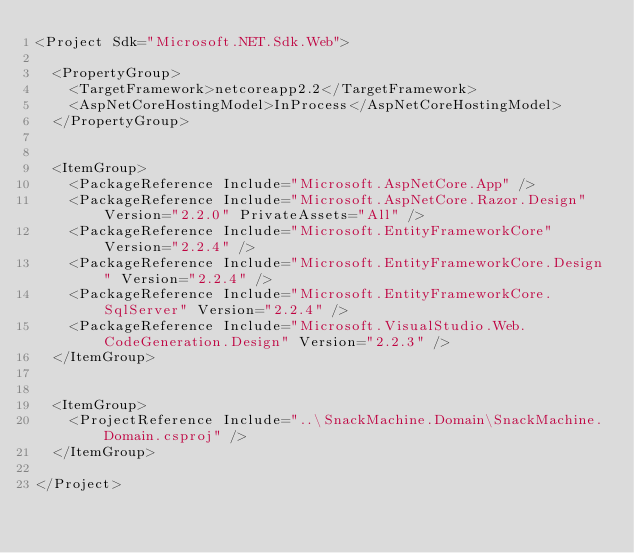Convert code to text. <code><loc_0><loc_0><loc_500><loc_500><_XML_><Project Sdk="Microsoft.NET.Sdk.Web">

  <PropertyGroup>
    <TargetFramework>netcoreapp2.2</TargetFramework>
    <AspNetCoreHostingModel>InProcess</AspNetCoreHostingModel>
  </PropertyGroup>


  <ItemGroup>
    <PackageReference Include="Microsoft.AspNetCore.App" />
    <PackageReference Include="Microsoft.AspNetCore.Razor.Design" Version="2.2.0" PrivateAssets="All" />
    <PackageReference Include="Microsoft.EntityFrameworkCore" Version="2.2.4" />
    <PackageReference Include="Microsoft.EntityFrameworkCore.Design" Version="2.2.4" />
    <PackageReference Include="Microsoft.EntityFrameworkCore.SqlServer" Version="2.2.4" />
    <PackageReference Include="Microsoft.VisualStudio.Web.CodeGeneration.Design" Version="2.2.3" />
  </ItemGroup>


  <ItemGroup>
    <ProjectReference Include="..\SnackMachine.Domain\SnackMachine.Domain.csproj" />
  </ItemGroup>

</Project>
</code> 